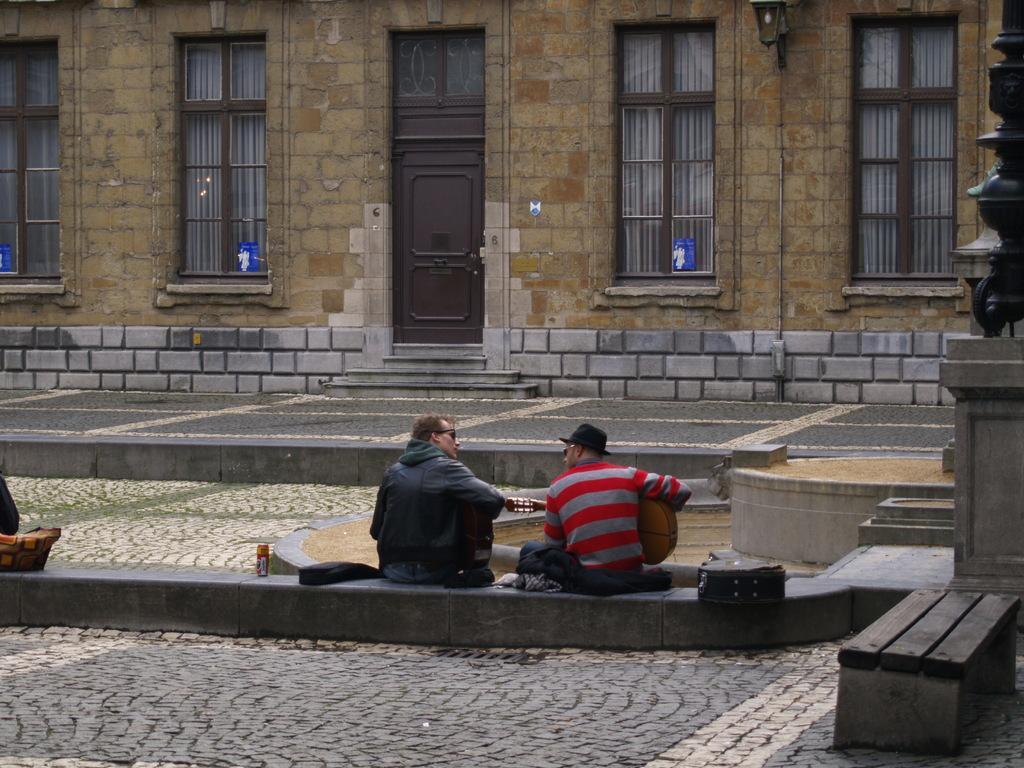In one or two sentences, can you explain what this image depicts? In this image I can see two men are sitting. I can also see a man is holding a guitar. In the background I can see a building and a door. 